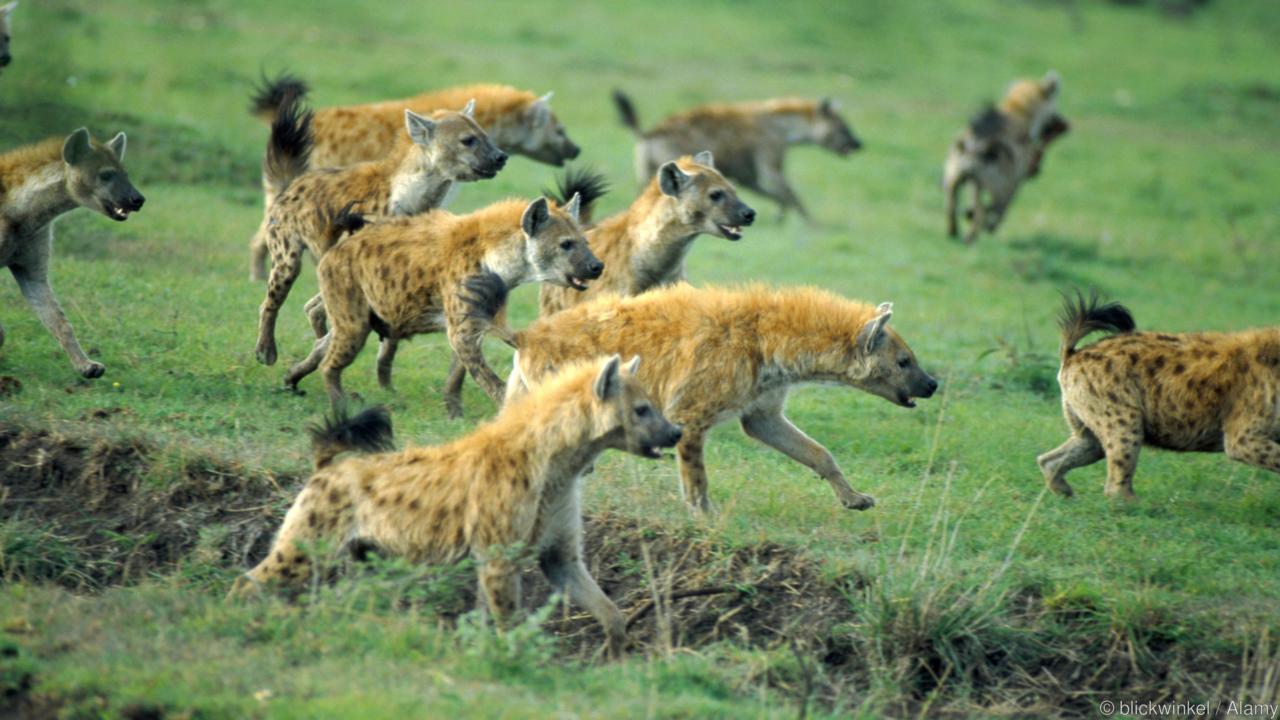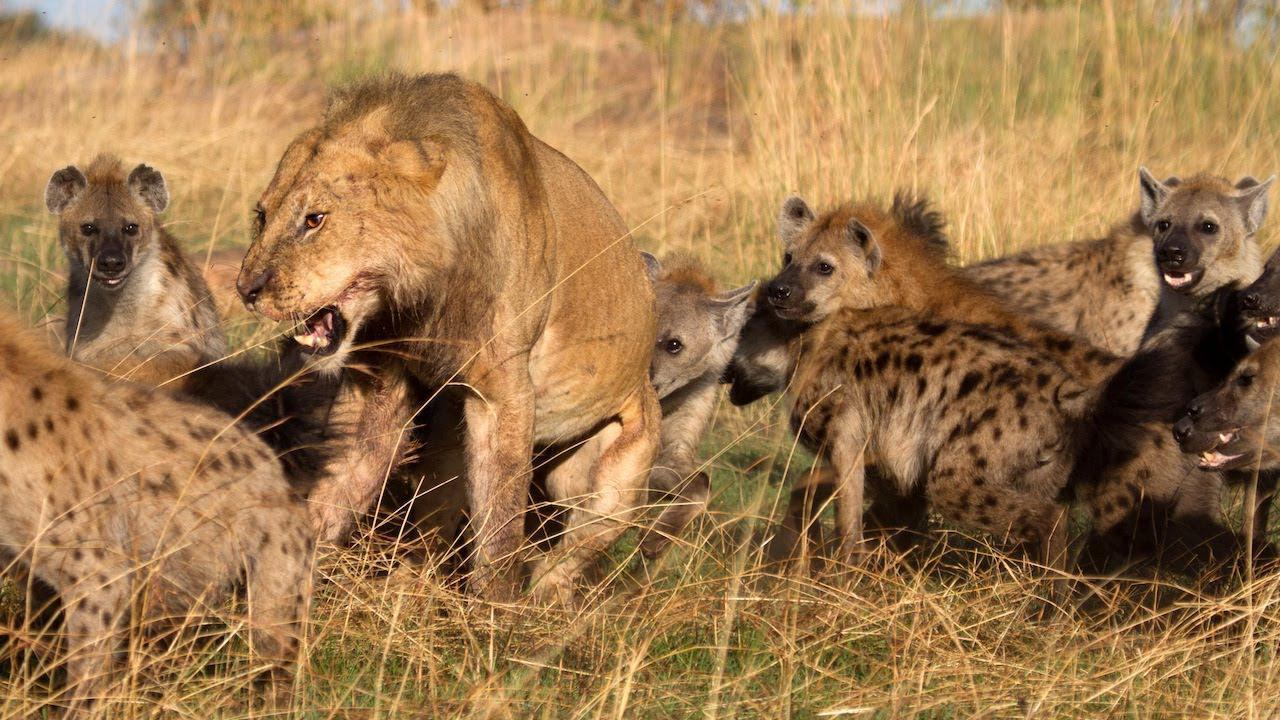The first image is the image on the left, the second image is the image on the right. Evaluate the accuracy of this statement regarding the images: "In one of the image the pack of hyenas are moving right.". Is it true? Answer yes or no. Yes. The first image is the image on the left, the second image is the image on the right. Assess this claim about the two images: "At least one image has a  single tan and black hyena opening its mouth showing its teeth.". Correct or not? Answer yes or no. No. 